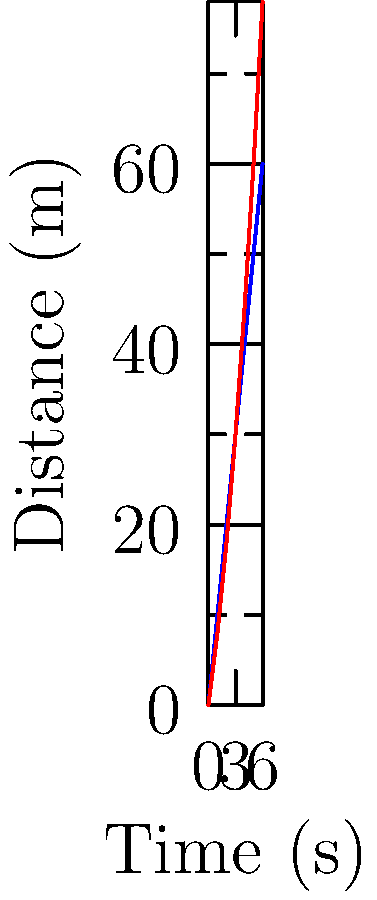The graph shows the distance covered by two rugby players (A and B) over time during a sprint drill. Calculate the average speed of Player B between 3 and 5 seconds, and determine which player has the higher instantaneous speed at the 4-second mark. To solve this problem, we'll follow these steps:

1. Calculate the average speed of Player B between 3 and 5 seconds:
   a. Find the distance covered by Player B from 3s to 5s:
      At 3s: 30m
      At 5s: 60m
      Distance covered = 60m - 30m = 30m
   b. Calculate the time interval: 5s - 3s = 2s
   c. Use the formula: Average Speed = Distance / Time
      Average Speed = 30m / 2s = 15 m/s

2. Determine which player has the higher instantaneous speed at 4 seconds:
   a. For Player A:
      At 3s: 30m
      At 5s: 50m
      Change in distance over 2s = 50m - 30m = 20m
      Instantaneous speed ≈ 20m / 2s = 10 m/s
   b. For Player B:
      At 3s: 30m
      At 5s: 60m
      Change in distance over 2s = 60m - 30m = 30m
      Instantaneous speed ≈ 30m / 2s = 15 m/s

Player B has the higher instantaneous speed at the 4-second mark.
Answer: Player B's average speed: 15 m/s. Player B has higher instantaneous speed at 4s. 